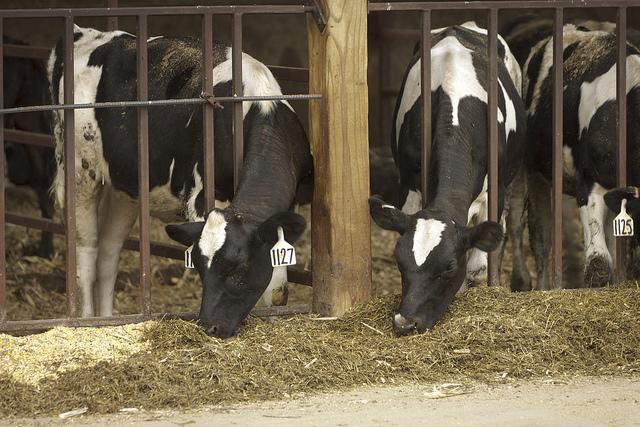Imagine a day in the life of one of these cows. Describe it from the cow's perspective. My day starts with the light streaming into the barn as the farmer opens the doors. I hear the familiar sounds of my fellow cows and the clinking of the metal bars as we all wake up. Soon, the farmer arrives with fresh feed, and I eagerly make my way to the trough, where I can smell the delicious hay and grains. After a hearty meal, I spend some time idly chewing cud, feeling relaxed and content. Later, I am guided to the milking area, where the automated milking machines gently relieve the pressure from my udder. Post-milking, I join my herd mates in a cozy corner of the barn for some rest. The day continues in this cycle of eating, milking, and resting, with the occasional visit from the farmer checking our health and comfort. As the sun sets, again the barn returns to a quieter state, and we all settle down for the night, ready to begin another day on the farm. 